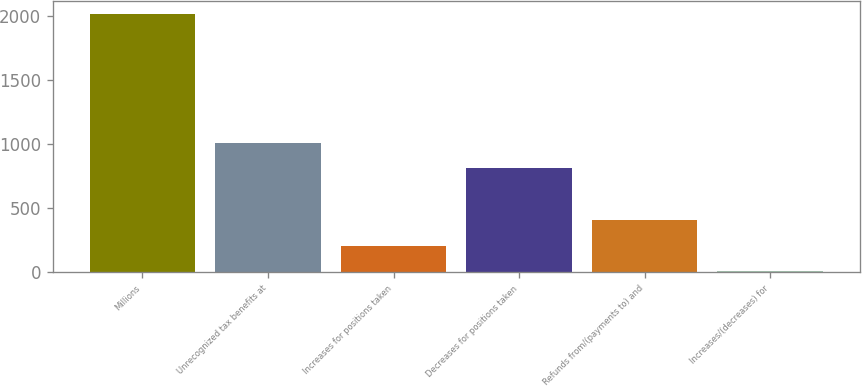Convert chart. <chart><loc_0><loc_0><loc_500><loc_500><bar_chart><fcel>Millions<fcel>Unrecognized tax benefits at<fcel>Increases for positions taken<fcel>Decreases for positions taken<fcel>Refunds from/(payments to) and<fcel>Increases/(decreases) for<nl><fcel>2015<fcel>1010<fcel>206<fcel>809<fcel>407<fcel>5<nl></chart> 